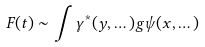Convert formula to latex. <formula><loc_0><loc_0><loc_500><loc_500>F ( t ) \sim \int \gamma ^ { * } ( y , \dots ) g \psi ( x , \dots )</formula> 